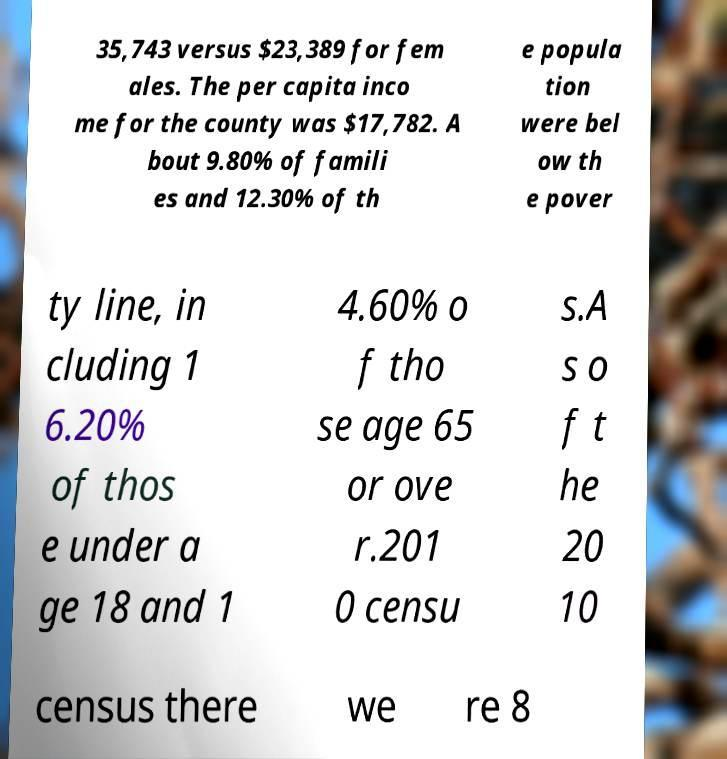Can you accurately transcribe the text from the provided image for me? 35,743 versus $23,389 for fem ales. The per capita inco me for the county was $17,782. A bout 9.80% of famili es and 12.30% of th e popula tion were bel ow th e pover ty line, in cluding 1 6.20% of thos e under a ge 18 and 1 4.60% o f tho se age 65 or ove r.201 0 censu s.A s o f t he 20 10 census there we re 8 